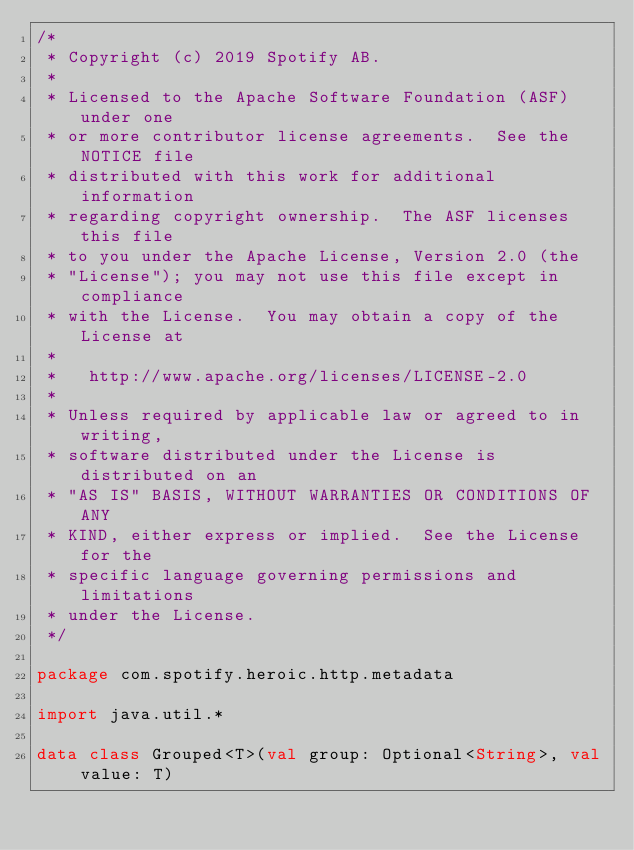Convert code to text. <code><loc_0><loc_0><loc_500><loc_500><_Kotlin_>/*
 * Copyright (c) 2019 Spotify AB.
 *
 * Licensed to the Apache Software Foundation (ASF) under one
 * or more contributor license agreements.  See the NOTICE file
 * distributed with this work for additional information
 * regarding copyright ownership.  The ASF licenses this file
 * to you under the Apache License, Version 2.0 (the
 * "License"); you may not use this file except in compliance
 * with the License.  You may obtain a copy of the License at
 *
 *   http://www.apache.org/licenses/LICENSE-2.0
 *
 * Unless required by applicable law or agreed to in writing,
 * software distributed under the License is distributed on an
 * "AS IS" BASIS, WITHOUT WARRANTIES OR CONDITIONS OF ANY
 * KIND, either express or implied.  See the License for the
 * specific language governing permissions and limitations
 * under the License.
 */

package com.spotify.heroic.http.metadata

import java.util.*

data class Grouped<T>(val group: Optional<String>, val value: T)</code> 